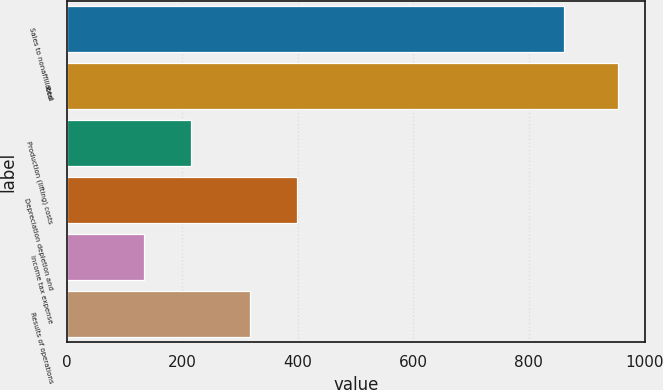Convert chart to OTSL. <chart><loc_0><loc_0><loc_500><loc_500><bar_chart><fcel>Sales to nonaffiliated<fcel>Total<fcel>Production (lifting) costs<fcel>Depreciation depletion and<fcel>Income tax expense<fcel>Results of operations<nl><fcel>861<fcel>954<fcel>216<fcel>399<fcel>134<fcel>317<nl></chart> 